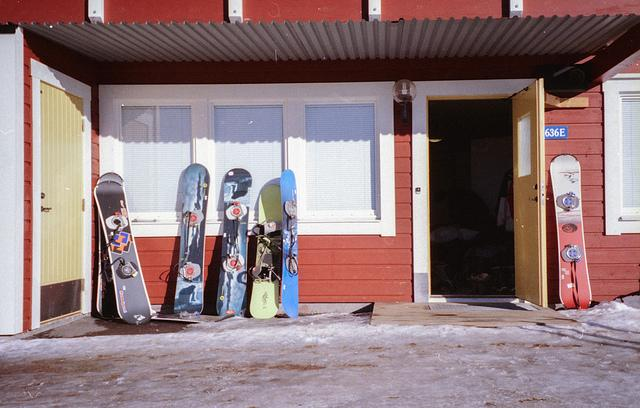What activity are the boards lined up against the building used for?

Choices:
A) football
B) skiing
C) soccer
D) snowboarding snowboarding 